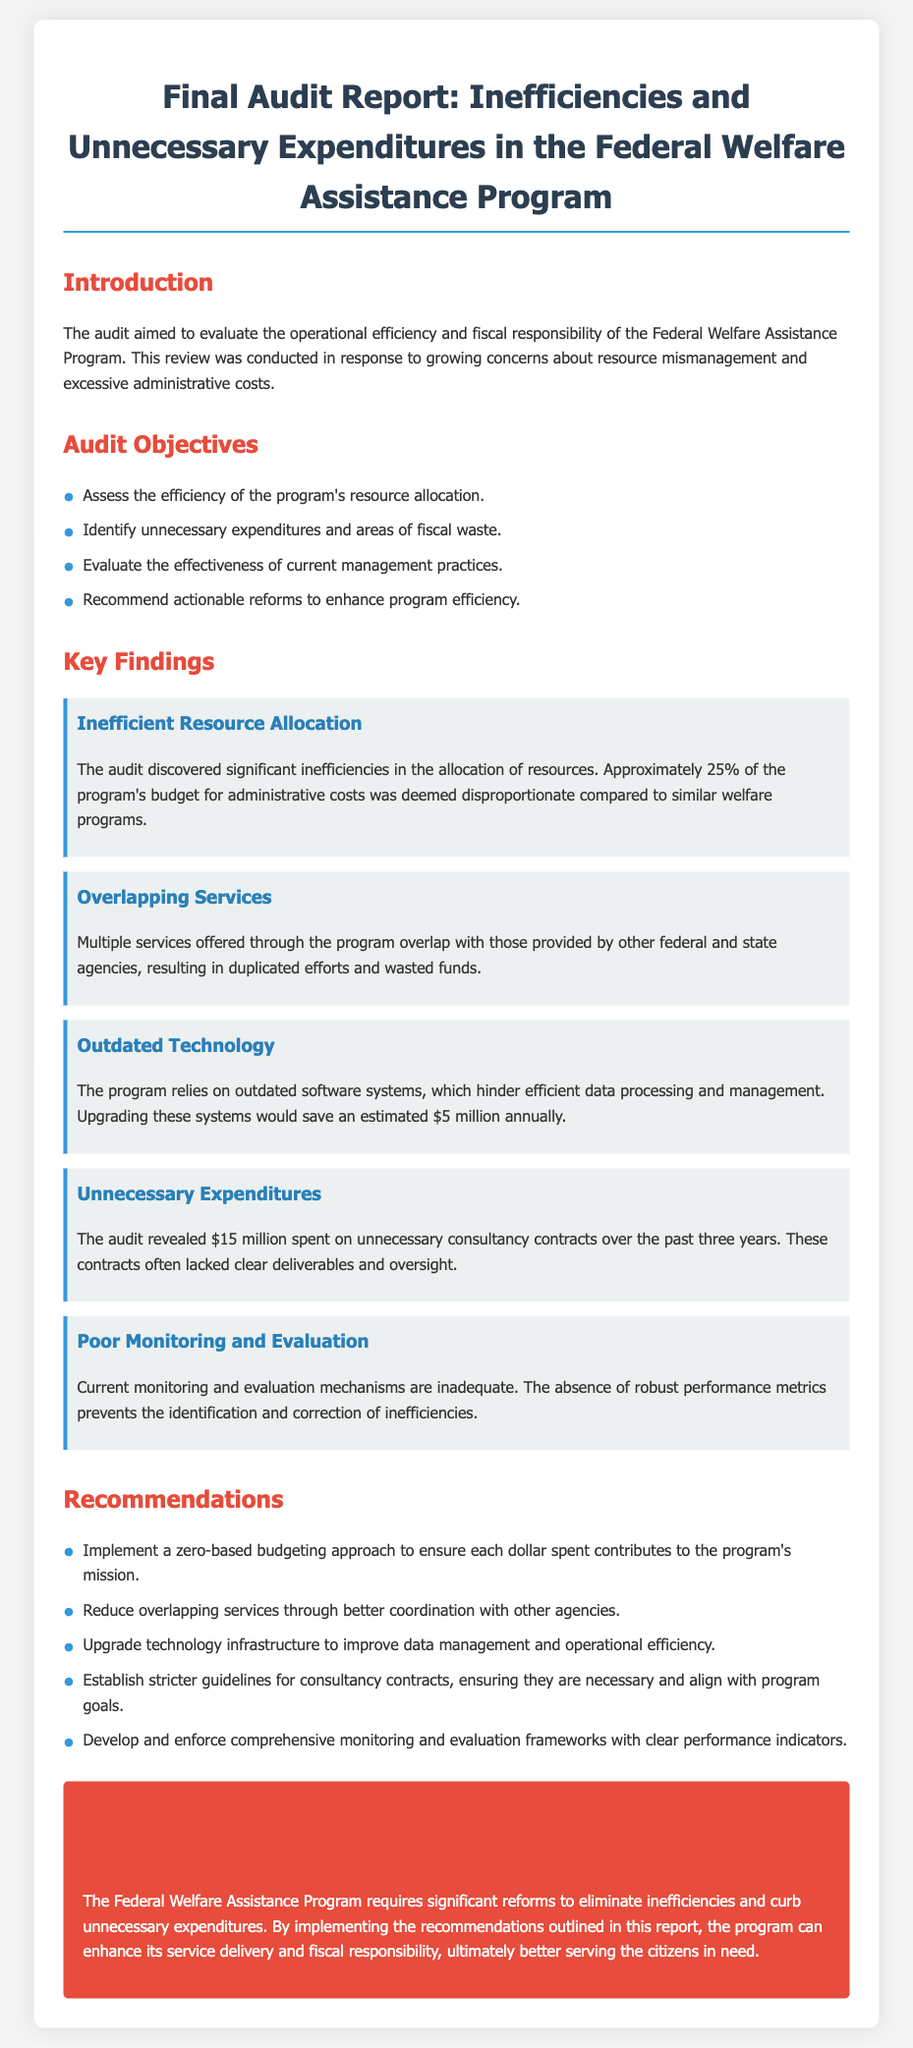What was the primary goal of the audit? The primary goal of the audit was to evaluate the operational efficiency and fiscal responsibility of the Federal Welfare Assistance Program.
Answer: operational efficiency and fiscal responsibility What percentage of the program's budget for administrative costs was deemed disproportionate? According to the report, approximately 25% of the program's budget for administrative costs was deemed disproportionate compared to similar welfare programs.
Answer: 25% How much could upgrading outdated systems save annually? The report states that upgrading outdated systems would save an estimated $5 million annually.
Answer: $5 million What amount was spent on unnecessary consultancy contracts over three years? The audit revealed that $15 million was spent on unnecessary consultancy contracts over the past three years.
Answer: $15 million What type of budgeting approach is recommended? The report recommends implementing a zero-based budgeting approach to ensure each dollar spent contributes to the program's mission.
Answer: zero-based budgeting Which finding involved duplication of efforts? The finding related to multiple services offered through the program overlapping with those provided by other federal and state agencies highlighted the issue of duplication of efforts and wasted funds.
Answer: Overlapping Services What is identified as inadequate in the current monitoring? The report identifies that the current monitoring and evaluation mechanisms are inadequate due to the absence of robust performance metrics.
Answer: inadequate What color coding is used for the key findings section? The color coding used for the key findings section is blue on a light gray background.
Answer: blue How many audit objectives are listed in the report? There are four audit objectives listed in the report to assess program efficiency and effectiveness.
Answer: four 